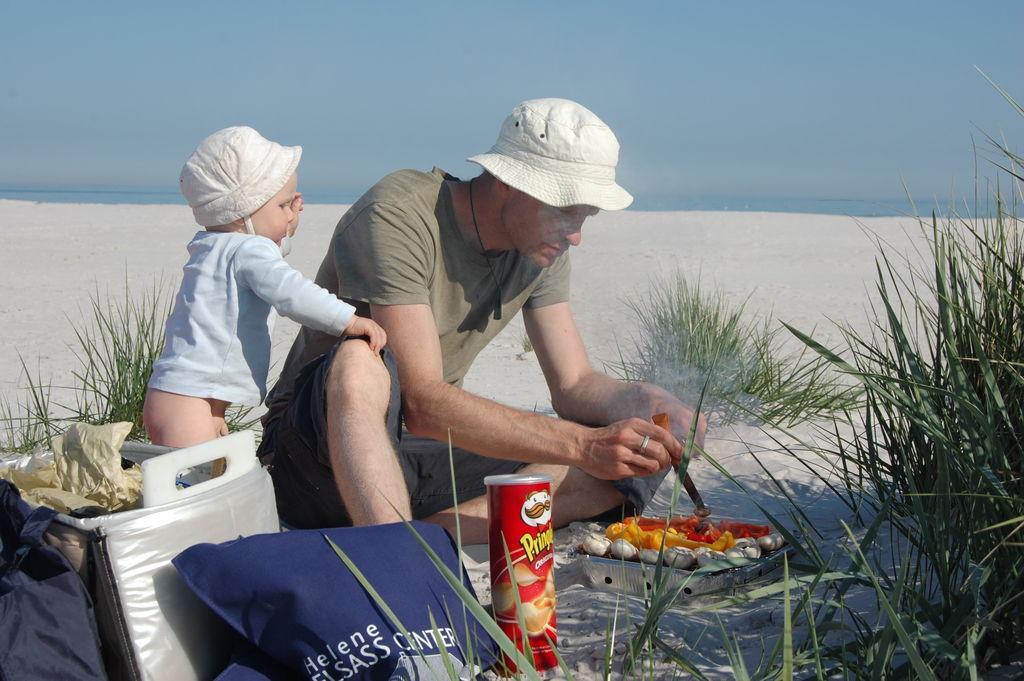Could you give a brief overview of what you see in this image? In the foreground, I can see some objects, food items and two persons on sand. In the background, I can see grass, water and the sky. This image taken, maybe on the sandy beach. 